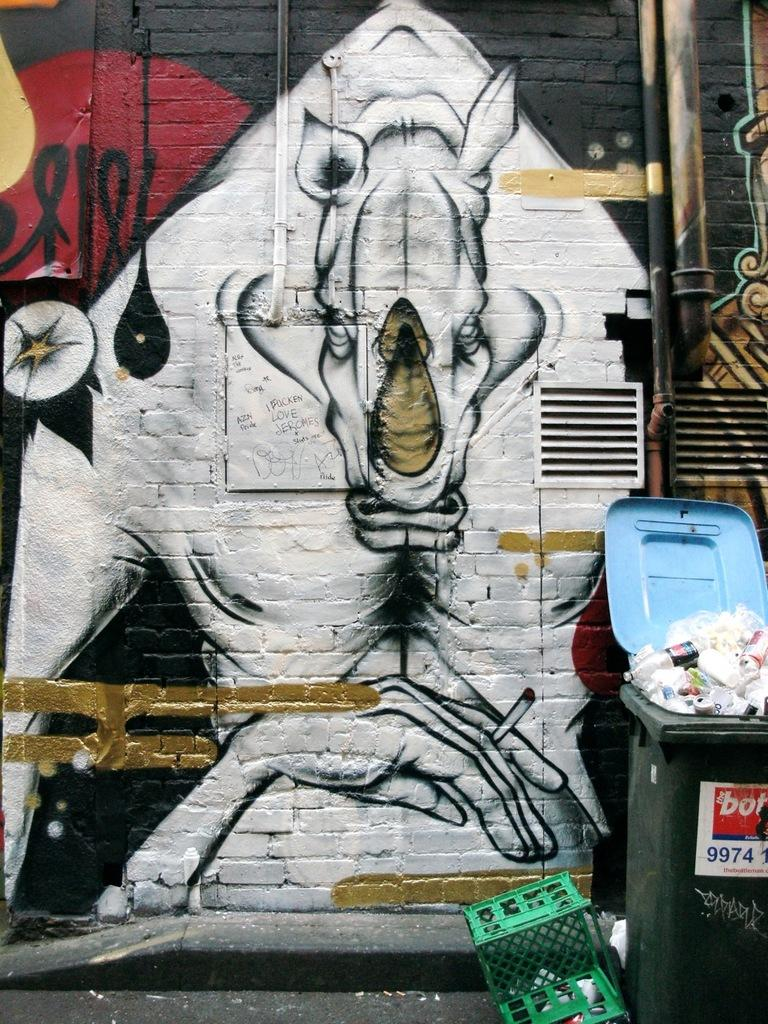<image>
Summarize the visual content of the image. the numbers 9974 are on the white sign 